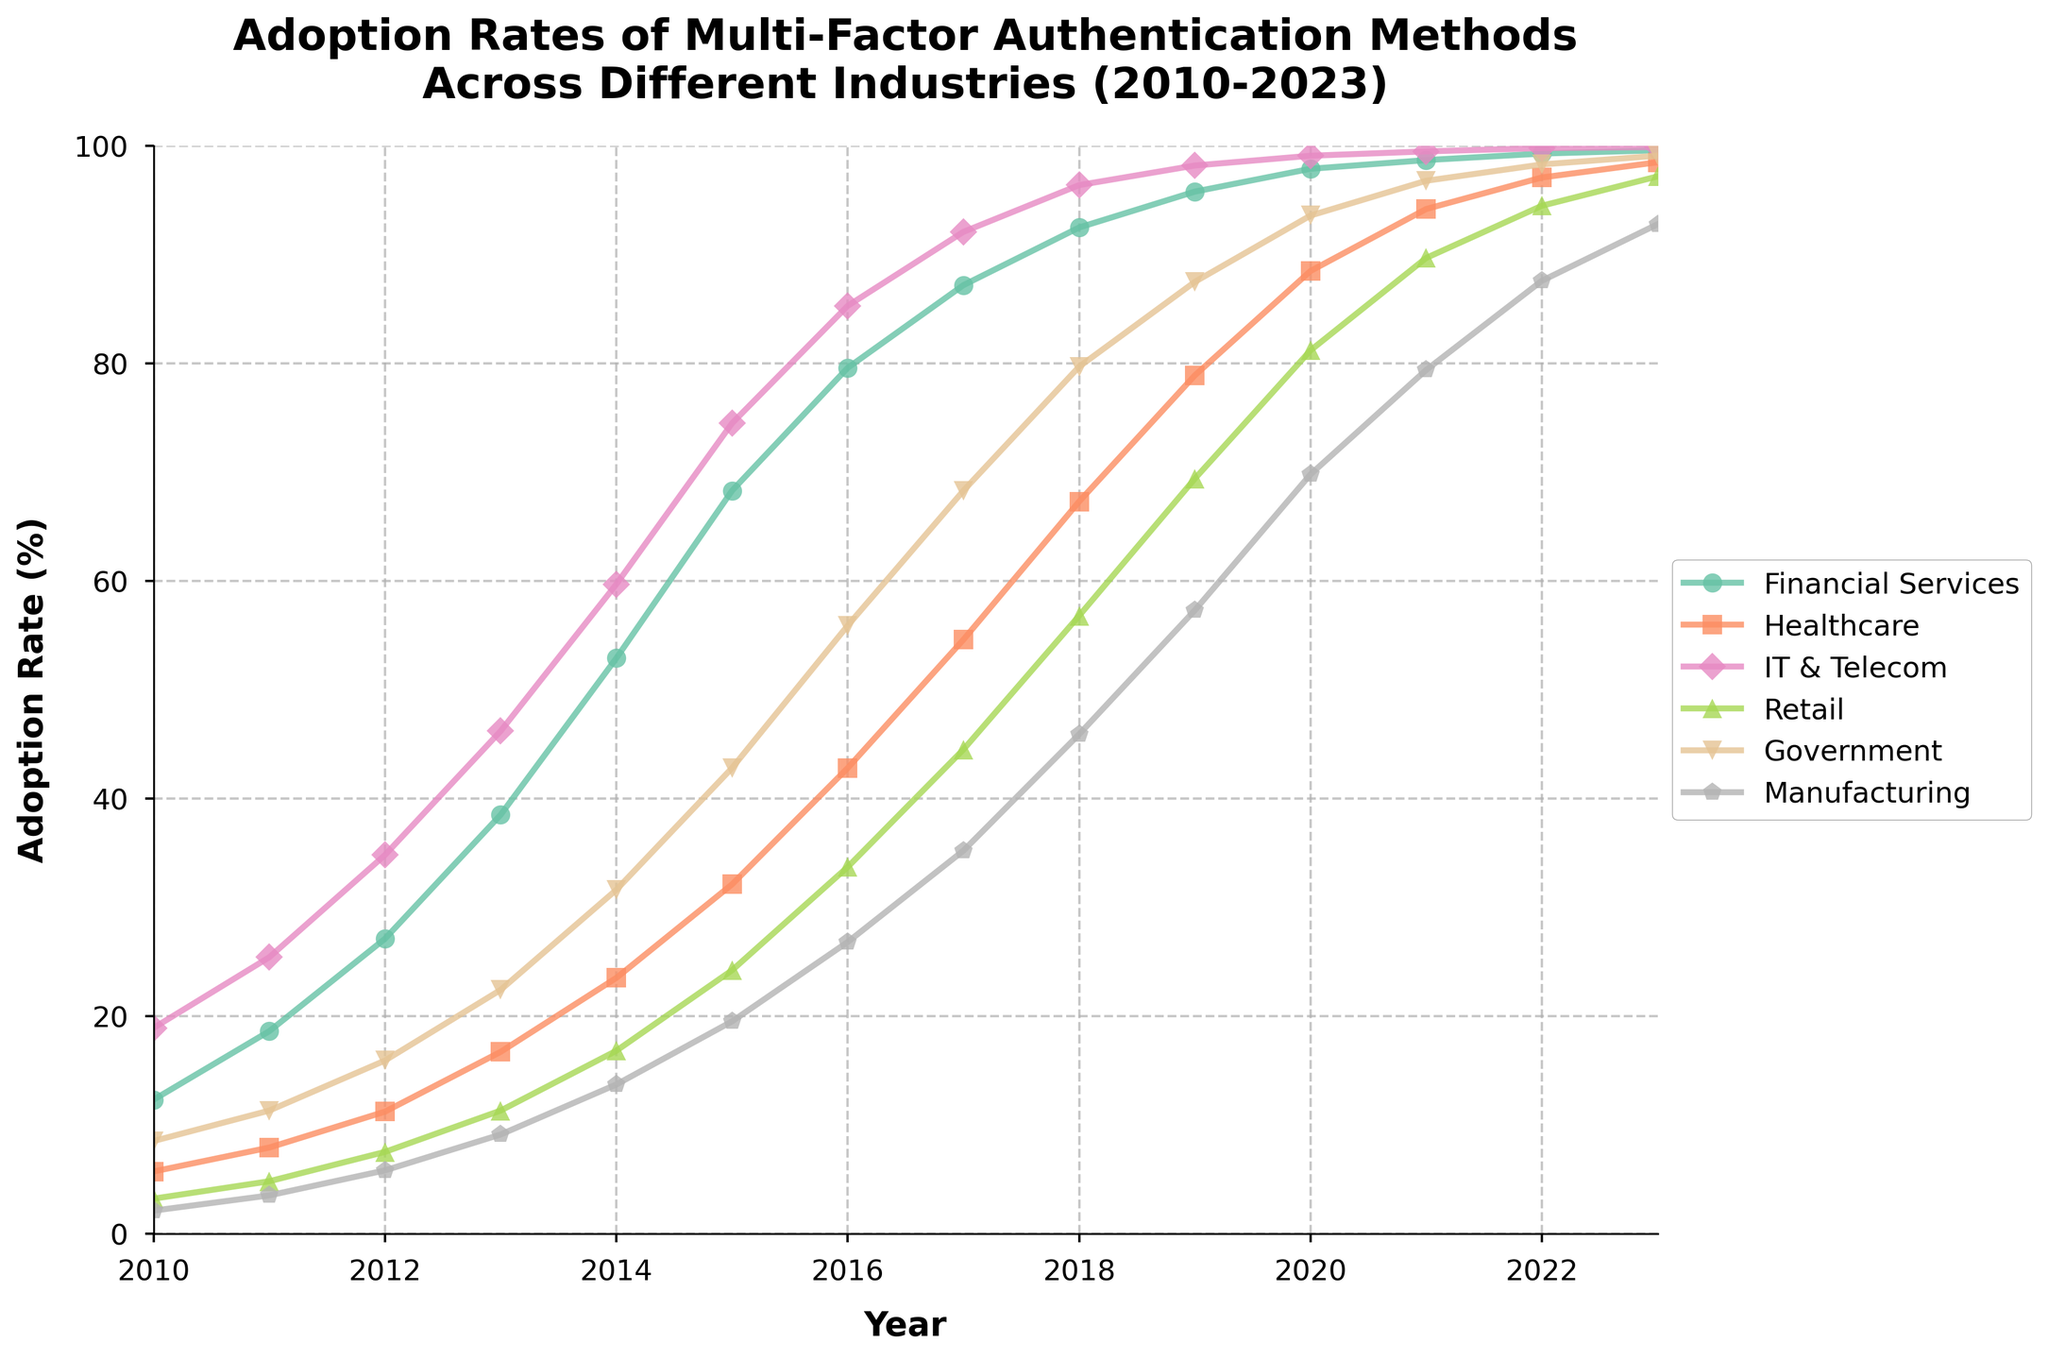Which industry had the highest adoption rate of multi-factor authentication in 2023? Look at the data points for the year 2023 and identify the industry with the highest value. Financial Services had 99.6%, Healthcare had 98.5%, IT & Telecom had 99.9%, Retail had 97.2%, Government had 99.1%, and Manufacturing had 92.8%. The highest value is 99.9% for IT & Telecom.
Answer: IT & Telecom In which year did the Financial Services industry exceed a 50% adoption rate? Look at the data for the Financial Services industry and identify the first year its adoption rate exceeded 50%. In 2010, it was 12.3%, in 2011 it was 18.6%, in 2012 it was 27.1%, in 2013 it was 38.5%, and in 2014 it was 52.9%. So, 2014 is the first year it exceeded 50%.
Answer: 2014 How does the adoption rate of multi-factor authentication in Healthcare in 2015 compare to that in Government in the same year? Look at the adoption rates for Healthcare and Government in 2015. Healthcare had a rate of 32.1%, while Government had a rate of 42.8%. Compare the two values directly. Government's rate is higher than Healthcare’s.
Answer: Government's rate is higher Which industry showed the most significant increase in adoption rate from 2010 to 2023? Calculate the increase for each industry from 2010 to 2023. Financial Services: 99.6% - 12.3% = 87.3%, Healthcare: 98.5% - 5.7% = 92.8%, IT & Telecom: 99.9% - 18.9% = 81.0%, Retail: 97.2% - 3.2% = 94.0%, Government: 99.1% - 8.5% = 90.6%, Manufacturing: 92.8% - 2.1% = 90.7%. Retail shows the highest increase with 94.0%.
Answer: Retail What is the range of the adoption rates for Manufacturing over the period 2010 to 2023? Identify the lowest and highest adoption rates for Manufacturing from 2010 to 2023. The lowest is in 2010 at 2.1%, and the highest is in 2023 at 92.8%. Calculate the range: 92.8% - 2.1% = 90.7%.
Answer: 90.7% Did the Government industry ever have a year where its adoption rate increased by more than 15% compared to the previous year? Look at the Government adoption rates year by year and calculate the differences with the previous year. From 2010 to 2011: 11.3% - 8.5% = 2.8%, from 2011 to 2012: 15.9% - 11.3% = 4.6%, and so on. The highest yearly increase is 11.0% from 2016 to 2017. No year shows an increase greater than 15%.
Answer: No 